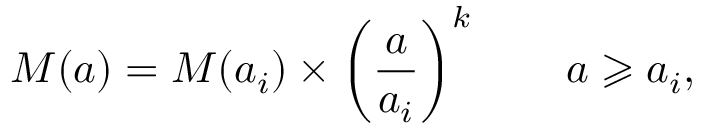<formula> <loc_0><loc_0><loc_500><loc_500>M ( a ) = M ( a _ { i } ) \times \left ( \frac { a } { a _ { i } } \right ) ^ { k } \quad a \geqslant a _ { i } ,</formula> 